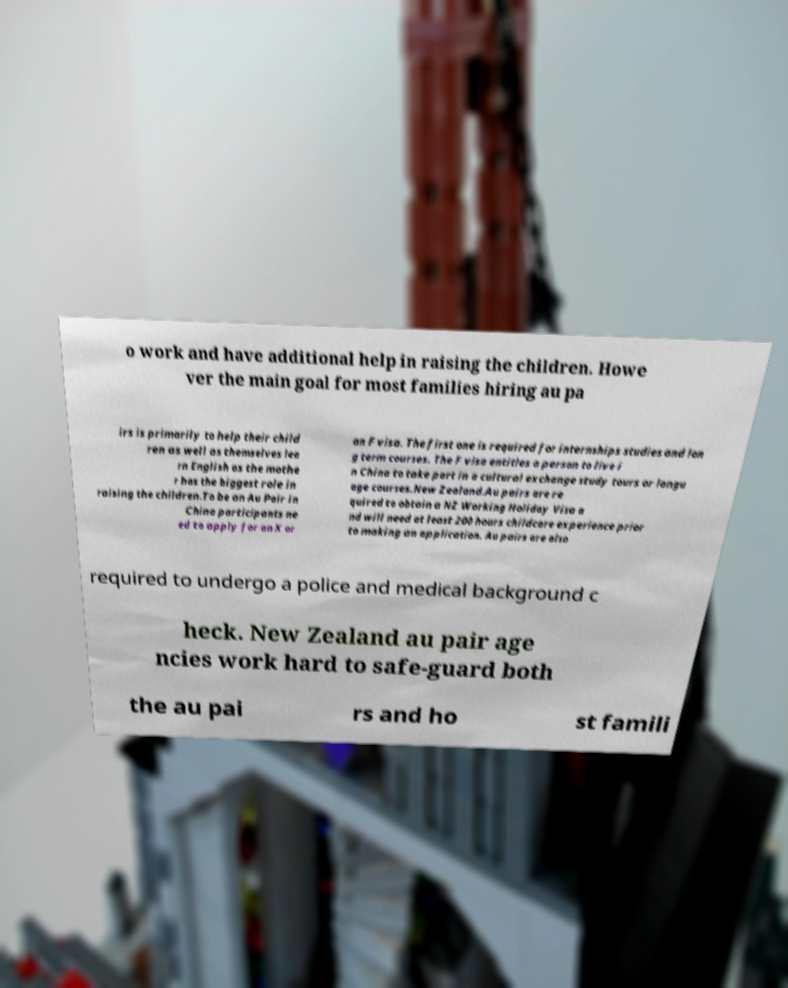There's text embedded in this image that I need extracted. Can you transcribe it verbatim? o work and have additional help in raising the children. Howe ver the main goal for most families hiring au pa irs is primarily to help their child ren as well as themselves lea rn English as the mothe r has the biggest role in raising the children.To be an Au Pair in China participants ne ed to apply for an X or an F visa. The first one is required for internships studies and lon g term courses. The F visa entitles a person to live i n China to take part in a cultural exchange study tours or langu age courses.New Zealand.Au pairs are re quired to obtain a NZ Working Holiday Visa a nd will need at least 200 hours childcare experience prior to making an application. Au pairs are also required to undergo a police and medical background c heck. New Zealand au pair age ncies work hard to safe-guard both the au pai rs and ho st famili 